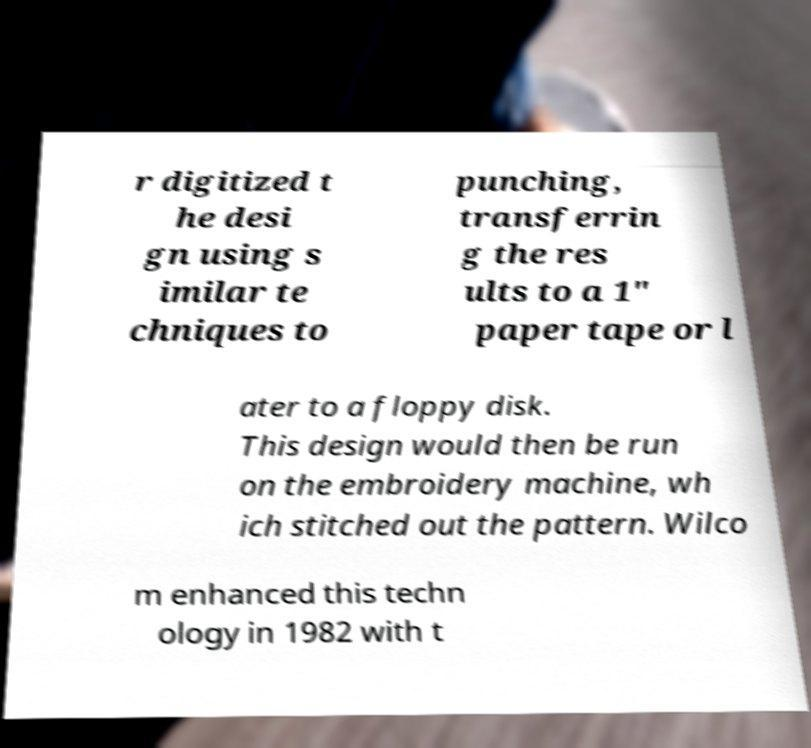What messages or text are displayed in this image? I need them in a readable, typed format. r digitized t he desi gn using s imilar te chniques to punching, transferrin g the res ults to a 1" paper tape or l ater to a floppy disk. This design would then be run on the embroidery machine, wh ich stitched out the pattern. Wilco m enhanced this techn ology in 1982 with t 